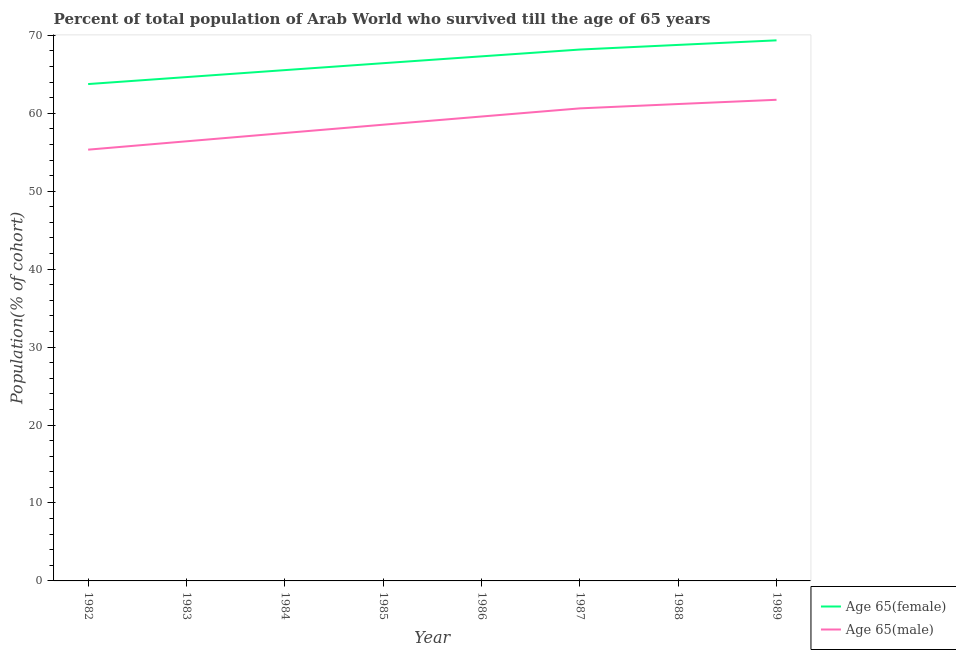Does the line corresponding to percentage of male population who survived till age of 65 intersect with the line corresponding to percentage of female population who survived till age of 65?
Ensure brevity in your answer.  No. What is the percentage of female population who survived till age of 65 in 1986?
Keep it short and to the point. 67.3. Across all years, what is the maximum percentage of male population who survived till age of 65?
Provide a succinct answer. 61.73. Across all years, what is the minimum percentage of female population who survived till age of 65?
Your answer should be compact. 63.75. In which year was the percentage of male population who survived till age of 65 minimum?
Offer a very short reply. 1982. What is the total percentage of female population who survived till age of 65 in the graph?
Keep it short and to the point. 533.96. What is the difference between the percentage of female population who survived till age of 65 in 1985 and that in 1987?
Your response must be concise. -1.75. What is the difference between the percentage of male population who survived till age of 65 in 1982 and the percentage of female population who survived till age of 65 in 1987?
Give a very brief answer. -12.84. What is the average percentage of male population who survived till age of 65 per year?
Ensure brevity in your answer.  58.86. In the year 1984, what is the difference between the percentage of male population who survived till age of 65 and percentage of female population who survived till age of 65?
Offer a very short reply. -8.07. In how many years, is the percentage of female population who survived till age of 65 greater than 8 %?
Keep it short and to the point. 8. What is the ratio of the percentage of male population who survived till age of 65 in 1987 to that in 1989?
Keep it short and to the point. 0.98. What is the difference between the highest and the second highest percentage of male population who survived till age of 65?
Offer a very short reply. 0.55. What is the difference between the highest and the lowest percentage of female population who survived till age of 65?
Ensure brevity in your answer.  5.61. Does the percentage of female population who survived till age of 65 monotonically increase over the years?
Make the answer very short. Yes. Is the percentage of female population who survived till age of 65 strictly less than the percentage of male population who survived till age of 65 over the years?
Ensure brevity in your answer.  No. How many lines are there?
Offer a very short reply. 2. Are the values on the major ticks of Y-axis written in scientific E-notation?
Your answer should be compact. No. Where does the legend appear in the graph?
Ensure brevity in your answer.  Bottom right. How many legend labels are there?
Offer a terse response. 2. How are the legend labels stacked?
Provide a short and direct response. Vertical. What is the title of the graph?
Provide a succinct answer. Percent of total population of Arab World who survived till the age of 65 years. Does "Number of departures" appear as one of the legend labels in the graph?
Keep it short and to the point. No. What is the label or title of the X-axis?
Offer a terse response. Year. What is the label or title of the Y-axis?
Keep it short and to the point. Population(% of cohort). What is the Population(% of cohort) of Age 65(female) in 1982?
Ensure brevity in your answer.  63.75. What is the Population(% of cohort) in Age 65(male) in 1982?
Offer a terse response. 55.33. What is the Population(% of cohort) of Age 65(female) in 1983?
Your response must be concise. 64.64. What is the Population(% of cohort) in Age 65(male) in 1983?
Provide a short and direct response. 56.4. What is the Population(% of cohort) of Age 65(female) in 1984?
Provide a short and direct response. 65.54. What is the Population(% of cohort) in Age 65(male) in 1984?
Your response must be concise. 57.47. What is the Population(% of cohort) in Age 65(female) in 1985?
Offer a very short reply. 66.42. What is the Population(% of cohort) in Age 65(male) in 1985?
Offer a terse response. 58.53. What is the Population(% of cohort) of Age 65(female) in 1986?
Keep it short and to the point. 67.3. What is the Population(% of cohort) of Age 65(male) in 1986?
Give a very brief answer. 59.58. What is the Population(% of cohort) in Age 65(female) in 1987?
Ensure brevity in your answer.  68.18. What is the Population(% of cohort) in Age 65(male) in 1987?
Offer a terse response. 60.63. What is the Population(% of cohort) in Age 65(female) in 1988?
Offer a very short reply. 68.77. What is the Population(% of cohort) in Age 65(male) in 1988?
Make the answer very short. 61.19. What is the Population(% of cohort) in Age 65(female) in 1989?
Offer a very short reply. 69.36. What is the Population(% of cohort) in Age 65(male) in 1989?
Your answer should be compact. 61.73. Across all years, what is the maximum Population(% of cohort) in Age 65(female)?
Your answer should be very brief. 69.36. Across all years, what is the maximum Population(% of cohort) of Age 65(male)?
Offer a very short reply. 61.73. Across all years, what is the minimum Population(% of cohort) in Age 65(female)?
Ensure brevity in your answer.  63.75. Across all years, what is the minimum Population(% of cohort) in Age 65(male)?
Offer a terse response. 55.33. What is the total Population(% of cohort) in Age 65(female) in the graph?
Ensure brevity in your answer.  533.96. What is the total Population(% of cohort) in Age 65(male) in the graph?
Keep it short and to the point. 470.87. What is the difference between the Population(% of cohort) in Age 65(female) in 1982 and that in 1983?
Offer a terse response. -0.9. What is the difference between the Population(% of cohort) in Age 65(male) in 1982 and that in 1983?
Make the answer very short. -1.07. What is the difference between the Population(% of cohort) of Age 65(female) in 1982 and that in 1984?
Your answer should be very brief. -1.79. What is the difference between the Population(% of cohort) in Age 65(male) in 1982 and that in 1984?
Your answer should be very brief. -2.14. What is the difference between the Population(% of cohort) of Age 65(female) in 1982 and that in 1985?
Provide a succinct answer. -2.68. What is the difference between the Population(% of cohort) of Age 65(male) in 1982 and that in 1985?
Offer a very short reply. -3.2. What is the difference between the Population(% of cohort) in Age 65(female) in 1982 and that in 1986?
Your answer should be compact. -3.56. What is the difference between the Population(% of cohort) in Age 65(male) in 1982 and that in 1986?
Offer a very short reply. -4.25. What is the difference between the Population(% of cohort) in Age 65(female) in 1982 and that in 1987?
Provide a short and direct response. -4.43. What is the difference between the Population(% of cohort) in Age 65(male) in 1982 and that in 1987?
Give a very brief answer. -5.3. What is the difference between the Population(% of cohort) of Age 65(female) in 1982 and that in 1988?
Offer a very short reply. -5.02. What is the difference between the Population(% of cohort) in Age 65(male) in 1982 and that in 1988?
Offer a very short reply. -5.85. What is the difference between the Population(% of cohort) of Age 65(female) in 1982 and that in 1989?
Your answer should be compact. -5.61. What is the difference between the Population(% of cohort) in Age 65(male) in 1982 and that in 1989?
Offer a very short reply. -6.4. What is the difference between the Population(% of cohort) of Age 65(female) in 1983 and that in 1984?
Ensure brevity in your answer.  -0.89. What is the difference between the Population(% of cohort) in Age 65(male) in 1983 and that in 1984?
Your answer should be compact. -1.07. What is the difference between the Population(% of cohort) in Age 65(female) in 1983 and that in 1985?
Give a very brief answer. -1.78. What is the difference between the Population(% of cohort) in Age 65(male) in 1983 and that in 1985?
Provide a short and direct response. -2.13. What is the difference between the Population(% of cohort) in Age 65(female) in 1983 and that in 1986?
Give a very brief answer. -2.66. What is the difference between the Population(% of cohort) of Age 65(male) in 1983 and that in 1986?
Offer a terse response. -3.18. What is the difference between the Population(% of cohort) of Age 65(female) in 1983 and that in 1987?
Your response must be concise. -3.53. What is the difference between the Population(% of cohort) in Age 65(male) in 1983 and that in 1987?
Provide a succinct answer. -4.23. What is the difference between the Population(% of cohort) of Age 65(female) in 1983 and that in 1988?
Offer a very short reply. -4.13. What is the difference between the Population(% of cohort) in Age 65(male) in 1983 and that in 1988?
Your answer should be compact. -4.78. What is the difference between the Population(% of cohort) in Age 65(female) in 1983 and that in 1989?
Offer a very short reply. -4.71. What is the difference between the Population(% of cohort) in Age 65(male) in 1983 and that in 1989?
Your answer should be compact. -5.33. What is the difference between the Population(% of cohort) in Age 65(female) in 1984 and that in 1985?
Your response must be concise. -0.89. What is the difference between the Population(% of cohort) in Age 65(male) in 1984 and that in 1985?
Provide a succinct answer. -1.06. What is the difference between the Population(% of cohort) of Age 65(female) in 1984 and that in 1986?
Provide a succinct answer. -1.77. What is the difference between the Population(% of cohort) in Age 65(male) in 1984 and that in 1986?
Give a very brief answer. -2.11. What is the difference between the Population(% of cohort) in Age 65(female) in 1984 and that in 1987?
Make the answer very short. -2.64. What is the difference between the Population(% of cohort) in Age 65(male) in 1984 and that in 1987?
Ensure brevity in your answer.  -3.16. What is the difference between the Population(% of cohort) of Age 65(female) in 1984 and that in 1988?
Your answer should be very brief. -3.23. What is the difference between the Population(% of cohort) in Age 65(male) in 1984 and that in 1988?
Your response must be concise. -3.72. What is the difference between the Population(% of cohort) in Age 65(female) in 1984 and that in 1989?
Ensure brevity in your answer.  -3.82. What is the difference between the Population(% of cohort) in Age 65(male) in 1984 and that in 1989?
Your response must be concise. -4.26. What is the difference between the Population(% of cohort) of Age 65(female) in 1985 and that in 1986?
Make the answer very short. -0.88. What is the difference between the Population(% of cohort) in Age 65(male) in 1985 and that in 1986?
Provide a succinct answer. -1.05. What is the difference between the Population(% of cohort) of Age 65(female) in 1985 and that in 1987?
Your answer should be very brief. -1.75. What is the difference between the Population(% of cohort) of Age 65(male) in 1985 and that in 1987?
Provide a short and direct response. -2.1. What is the difference between the Population(% of cohort) in Age 65(female) in 1985 and that in 1988?
Give a very brief answer. -2.35. What is the difference between the Population(% of cohort) in Age 65(male) in 1985 and that in 1988?
Provide a succinct answer. -2.65. What is the difference between the Population(% of cohort) in Age 65(female) in 1985 and that in 1989?
Provide a short and direct response. -2.93. What is the difference between the Population(% of cohort) of Age 65(male) in 1985 and that in 1989?
Give a very brief answer. -3.2. What is the difference between the Population(% of cohort) in Age 65(female) in 1986 and that in 1987?
Keep it short and to the point. -0.87. What is the difference between the Population(% of cohort) of Age 65(male) in 1986 and that in 1987?
Your answer should be very brief. -1.04. What is the difference between the Population(% of cohort) in Age 65(female) in 1986 and that in 1988?
Your answer should be compact. -1.47. What is the difference between the Population(% of cohort) of Age 65(male) in 1986 and that in 1988?
Your answer should be compact. -1.6. What is the difference between the Population(% of cohort) of Age 65(female) in 1986 and that in 1989?
Give a very brief answer. -2.05. What is the difference between the Population(% of cohort) in Age 65(male) in 1986 and that in 1989?
Keep it short and to the point. -2.15. What is the difference between the Population(% of cohort) of Age 65(female) in 1987 and that in 1988?
Your response must be concise. -0.6. What is the difference between the Population(% of cohort) of Age 65(male) in 1987 and that in 1988?
Keep it short and to the point. -0.56. What is the difference between the Population(% of cohort) of Age 65(female) in 1987 and that in 1989?
Give a very brief answer. -1.18. What is the difference between the Population(% of cohort) of Age 65(male) in 1987 and that in 1989?
Ensure brevity in your answer.  -1.1. What is the difference between the Population(% of cohort) in Age 65(female) in 1988 and that in 1989?
Offer a terse response. -0.59. What is the difference between the Population(% of cohort) of Age 65(male) in 1988 and that in 1989?
Your answer should be very brief. -0.55. What is the difference between the Population(% of cohort) in Age 65(female) in 1982 and the Population(% of cohort) in Age 65(male) in 1983?
Your answer should be compact. 7.34. What is the difference between the Population(% of cohort) of Age 65(female) in 1982 and the Population(% of cohort) of Age 65(male) in 1984?
Your answer should be very brief. 6.28. What is the difference between the Population(% of cohort) of Age 65(female) in 1982 and the Population(% of cohort) of Age 65(male) in 1985?
Give a very brief answer. 5.21. What is the difference between the Population(% of cohort) in Age 65(female) in 1982 and the Population(% of cohort) in Age 65(male) in 1986?
Your answer should be compact. 4.16. What is the difference between the Population(% of cohort) of Age 65(female) in 1982 and the Population(% of cohort) of Age 65(male) in 1987?
Your answer should be compact. 3.12. What is the difference between the Population(% of cohort) in Age 65(female) in 1982 and the Population(% of cohort) in Age 65(male) in 1988?
Offer a very short reply. 2.56. What is the difference between the Population(% of cohort) in Age 65(female) in 1982 and the Population(% of cohort) in Age 65(male) in 1989?
Keep it short and to the point. 2.02. What is the difference between the Population(% of cohort) of Age 65(female) in 1983 and the Population(% of cohort) of Age 65(male) in 1984?
Provide a succinct answer. 7.17. What is the difference between the Population(% of cohort) of Age 65(female) in 1983 and the Population(% of cohort) of Age 65(male) in 1985?
Ensure brevity in your answer.  6.11. What is the difference between the Population(% of cohort) of Age 65(female) in 1983 and the Population(% of cohort) of Age 65(male) in 1986?
Your answer should be compact. 5.06. What is the difference between the Population(% of cohort) of Age 65(female) in 1983 and the Population(% of cohort) of Age 65(male) in 1987?
Your response must be concise. 4.01. What is the difference between the Population(% of cohort) of Age 65(female) in 1983 and the Population(% of cohort) of Age 65(male) in 1988?
Provide a short and direct response. 3.46. What is the difference between the Population(% of cohort) of Age 65(female) in 1983 and the Population(% of cohort) of Age 65(male) in 1989?
Give a very brief answer. 2.91. What is the difference between the Population(% of cohort) in Age 65(female) in 1984 and the Population(% of cohort) in Age 65(male) in 1985?
Offer a terse response. 7. What is the difference between the Population(% of cohort) in Age 65(female) in 1984 and the Population(% of cohort) in Age 65(male) in 1986?
Your response must be concise. 5.95. What is the difference between the Population(% of cohort) in Age 65(female) in 1984 and the Population(% of cohort) in Age 65(male) in 1987?
Offer a terse response. 4.91. What is the difference between the Population(% of cohort) of Age 65(female) in 1984 and the Population(% of cohort) of Age 65(male) in 1988?
Offer a terse response. 4.35. What is the difference between the Population(% of cohort) in Age 65(female) in 1984 and the Population(% of cohort) in Age 65(male) in 1989?
Your answer should be very brief. 3.8. What is the difference between the Population(% of cohort) in Age 65(female) in 1985 and the Population(% of cohort) in Age 65(male) in 1986?
Make the answer very short. 6.84. What is the difference between the Population(% of cohort) of Age 65(female) in 1985 and the Population(% of cohort) of Age 65(male) in 1987?
Give a very brief answer. 5.8. What is the difference between the Population(% of cohort) in Age 65(female) in 1985 and the Population(% of cohort) in Age 65(male) in 1988?
Provide a succinct answer. 5.24. What is the difference between the Population(% of cohort) in Age 65(female) in 1985 and the Population(% of cohort) in Age 65(male) in 1989?
Keep it short and to the point. 4.69. What is the difference between the Population(% of cohort) of Age 65(female) in 1986 and the Population(% of cohort) of Age 65(male) in 1987?
Offer a terse response. 6.68. What is the difference between the Population(% of cohort) in Age 65(female) in 1986 and the Population(% of cohort) in Age 65(male) in 1988?
Your response must be concise. 6.12. What is the difference between the Population(% of cohort) of Age 65(female) in 1986 and the Population(% of cohort) of Age 65(male) in 1989?
Provide a short and direct response. 5.57. What is the difference between the Population(% of cohort) in Age 65(female) in 1987 and the Population(% of cohort) in Age 65(male) in 1988?
Your response must be concise. 6.99. What is the difference between the Population(% of cohort) of Age 65(female) in 1987 and the Population(% of cohort) of Age 65(male) in 1989?
Make the answer very short. 6.44. What is the difference between the Population(% of cohort) of Age 65(female) in 1988 and the Population(% of cohort) of Age 65(male) in 1989?
Keep it short and to the point. 7.04. What is the average Population(% of cohort) of Age 65(female) per year?
Offer a terse response. 66.74. What is the average Population(% of cohort) of Age 65(male) per year?
Your response must be concise. 58.86. In the year 1982, what is the difference between the Population(% of cohort) of Age 65(female) and Population(% of cohort) of Age 65(male)?
Make the answer very short. 8.42. In the year 1983, what is the difference between the Population(% of cohort) of Age 65(female) and Population(% of cohort) of Age 65(male)?
Your response must be concise. 8.24. In the year 1984, what is the difference between the Population(% of cohort) of Age 65(female) and Population(% of cohort) of Age 65(male)?
Ensure brevity in your answer.  8.07. In the year 1985, what is the difference between the Population(% of cohort) of Age 65(female) and Population(% of cohort) of Age 65(male)?
Provide a short and direct response. 7.89. In the year 1986, what is the difference between the Population(% of cohort) in Age 65(female) and Population(% of cohort) in Age 65(male)?
Give a very brief answer. 7.72. In the year 1987, what is the difference between the Population(% of cohort) of Age 65(female) and Population(% of cohort) of Age 65(male)?
Your answer should be compact. 7.55. In the year 1988, what is the difference between the Population(% of cohort) in Age 65(female) and Population(% of cohort) in Age 65(male)?
Provide a succinct answer. 7.58. In the year 1989, what is the difference between the Population(% of cohort) of Age 65(female) and Population(% of cohort) of Age 65(male)?
Keep it short and to the point. 7.63. What is the ratio of the Population(% of cohort) of Age 65(female) in 1982 to that in 1983?
Your answer should be very brief. 0.99. What is the ratio of the Population(% of cohort) in Age 65(male) in 1982 to that in 1983?
Your answer should be very brief. 0.98. What is the ratio of the Population(% of cohort) of Age 65(female) in 1982 to that in 1984?
Provide a succinct answer. 0.97. What is the ratio of the Population(% of cohort) of Age 65(male) in 1982 to that in 1984?
Give a very brief answer. 0.96. What is the ratio of the Population(% of cohort) of Age 65(female) in 1982 to that in 1985?
Your answer should be compact. 0.96. What is the ratio of the Population(% of cohort) in Age 65(male) in 1982 to that in 1985?
Provide a short and direct response. 0.95. What is the ratio of the Population(% of cohort) of Age 65(female) in 1982 to that in 1986?
Offer a terse response. 0.95. What is the ratio of the Population(% of cohort) of Age 65(female) in 1982 to that in 1987?
Ensure brevity in your answer.  0.94. What is the ratio of the Population(% of cohort) in Age 65(male) in 1982 to that in 1987?
Provide a short and direct response. 0.91. What is the ratio of the Population(% of cohort) in Age 65(female) in 1982 to that in 1988?
Make the answer very short. 0.93. What is the ratio of the Population(% of cohort) of Age 65(male) in 1982 to that in 1988?
Provide a succinct answer. 0.9. What is the ratio of the Population(% of cohort) in Age 65(female) in 1982 to that in 1989?
Provide a short and direct response. 0.92. What is the ratio of the Population(% of cohort) of Age 65(male) in 1982 to that in 1989?
Offer a terse response. 0.9. What is the ratio of the Population(% of cohort) of Age 65(female) in 1983 to that in 1984?
Give a very brief answer. 0.99. What is the ratio of the Population(% of cohort) in Age 65(male) in 1983 to that in 1984?
Offer a very short reply. 0.98. What is the ratio of the Population(% of cohort) in Age 65(female) in 1983 to that in 1985?
Your response must be concise. 0.97. What is the ratio of the Population(% of cohort) of Age 65(male) in 1983 to that in 1985?
Offer a very short reply. 0.96. What is the ratio of the Population(% of cohort) of Age 65(female) in 1983 to that in 1986?
Keep it short and to the point. 0.96. What is the ratio of the Population(% of cohort) of Age 65(male) in 1983 to that in 1986?
Make the answer very short. 0.95. What is the ratio of the Population(% of cohort) in Age 65(female) in 1983 to that in 1987?
Your response must be concise. 0.95. What is the ratio of the Population(% of cohort) in Age 65(male) in 1983 to that in 1987?
Provide a succinct answer. 0.93. What is the ratio of the Population(% of cohort) in Age 65(male) in 1983 to that in 1988?
Give a very brief answer. 0.92. What is the ratio of the Population(% of cohort) in Age 65(female) in 1983 to that in 1989?
Keep it short and to the point. 0.93. What is the ratio of the Population(% of cohort) in Age 65(male) in 1983 to that in 1989?
Offer a terse response. 0.91. What is the ratio of the Population(% of cohort) of Age 65(female) in 1984 to that in 1985?
Your answer should be compact. 0.99. What is the ratio of the Population(% of cohort) in Age 65(male) in 1984 to that in 1985?
Provide a short and direct response. 0.98. What is the ratio of the Population(% of cohort) of Age 65(female) in 1984 to that in 1986?
Offer a terse response. 0.97. What is the ratio of the Population(% of cohort) in Age 65(male) in 1984 to that in 1986?
Your answer should be very brief. 0.96. What is the ratio of the Population(% of cohort) in Age 65(female) in 1984 to that in 1987?
Your answer should be very brief. 0.96. What is the ratio of the Population(% of cohort) of Age 65(male) in 1984 to that in 1987?
Your answer should be very brief. 0.95. What is the ratio of the Population(% of cohort) of Age 65(female) in 1984 to that in 1988?
Ensure brevity in your answer.  0.95. What is the ratio of the Population(% of cohort) in Age 65(male) in 1984 to that in 1988?
Provide a short and direct response. 0.94. What is the ratio of the Population(% of cohort) in Age 65(female) in 1984 to that in 1989?
Ensure brevity in your answer.  0.94. What is the ratio of the Population(% of cohort) in Age 65(male) in 1984 to that in 1989?
Provide a short and direct response. 0.93. What is the ratio of the Population(% of cohort) of Age 65(female) in 1985 to that in 1986?
Provide a short and direct response. 0.99. What is the ratio of the Population(% of cohort) of Age 65(male) in 1985 to that in 1986?
Your response must be concise. 0.98. What is the ratio of the Population(% of cohort) of Age 65(female) in 1985 to that in 1987?
Make the answer very short. 0.97. What is the ratio of the Population(% of cohort) in Age 65(male) in 1985 to that in 1987?
Provide a short and direct response. 0.97. What is the ratio of the Population(% of cohort) in Age 65(female) in 1985 to that in 1988?
Your answer should be compact. 0.97. What is the ratio of the Population(% of cohort) of Age 65(male) in 1985 to that in 1988?
Your answer should be compact. 0.96. What is the ratio of the Population(% of cohort) of Age 65(female) in 1985 to that in 1989?
Your answer should be very brief. 0.96. What is the ratio of the Population(% of cohort) in Age 65(male) in 1985 to that in 1989?
Offer a terse response. 0.95. What is the ratio of the Population(% of cohort) in Age 65(female) in 1986 to that in 1987?
Give a very brief answer. 0.99. What is the ratio of the Population(% of cohort) in Age 65(male) in 1986 to that in 1987?
Offer a terse response. 0.98. What is the ratio of the Population(% of cohort) of Age 65(female) in 1986 to that in 1988?
Your answer should be very brief. 0.98. What is the ratio of the Population(% of cohort) of Age 65(male) in 1986 to that in 1988?
Provide a succinct answer. 0.97. What is the ratio of the Population(% of cohort) in Age 65(female) in 1986 to that in 1989?
Provide a short and direct response. 0.97. What is the ratio of the Population(% of cohort) of Age 65(male) in 1986 to that in 1989?
Offer a very short reply. 0.97. What is the ratio of the Population(% of cohort) in Age 65(female) in 1987 to that in 1988?
Offer a very short reply. 0.99. What is the ratio of the Population(% of cohort) of Age 65(male) in 1987 to that in 1988?
Make the answer very short. 0.99. What is the ratio of the Population(% of cohort) of Age 65(male) in 1987 to that in 1989?
Your answer should be very brief. 0.98. What is the ratio of the Population(% of cohort) in Age 65(female) in 1988 to that in 1989?
Make the answer very short. 0.99. What is the difference between the highest and the second highest Population(% of cohort) of Age 65(female)?
Offer a terse response. 0.59. What is the difference between the highest and the second highest Population(% of cohort) of Age 65(male)?
Give a very brief answer. 0.55. What is the difference between the highest and the lowest Population(% of cohort) in Age 65(female)?
Keep it short and to the point. 5.61. What is the difference between the highest and the lowest Population(% of cohort) of Age 65(male)?
Give a very brief answer. 6.4. 